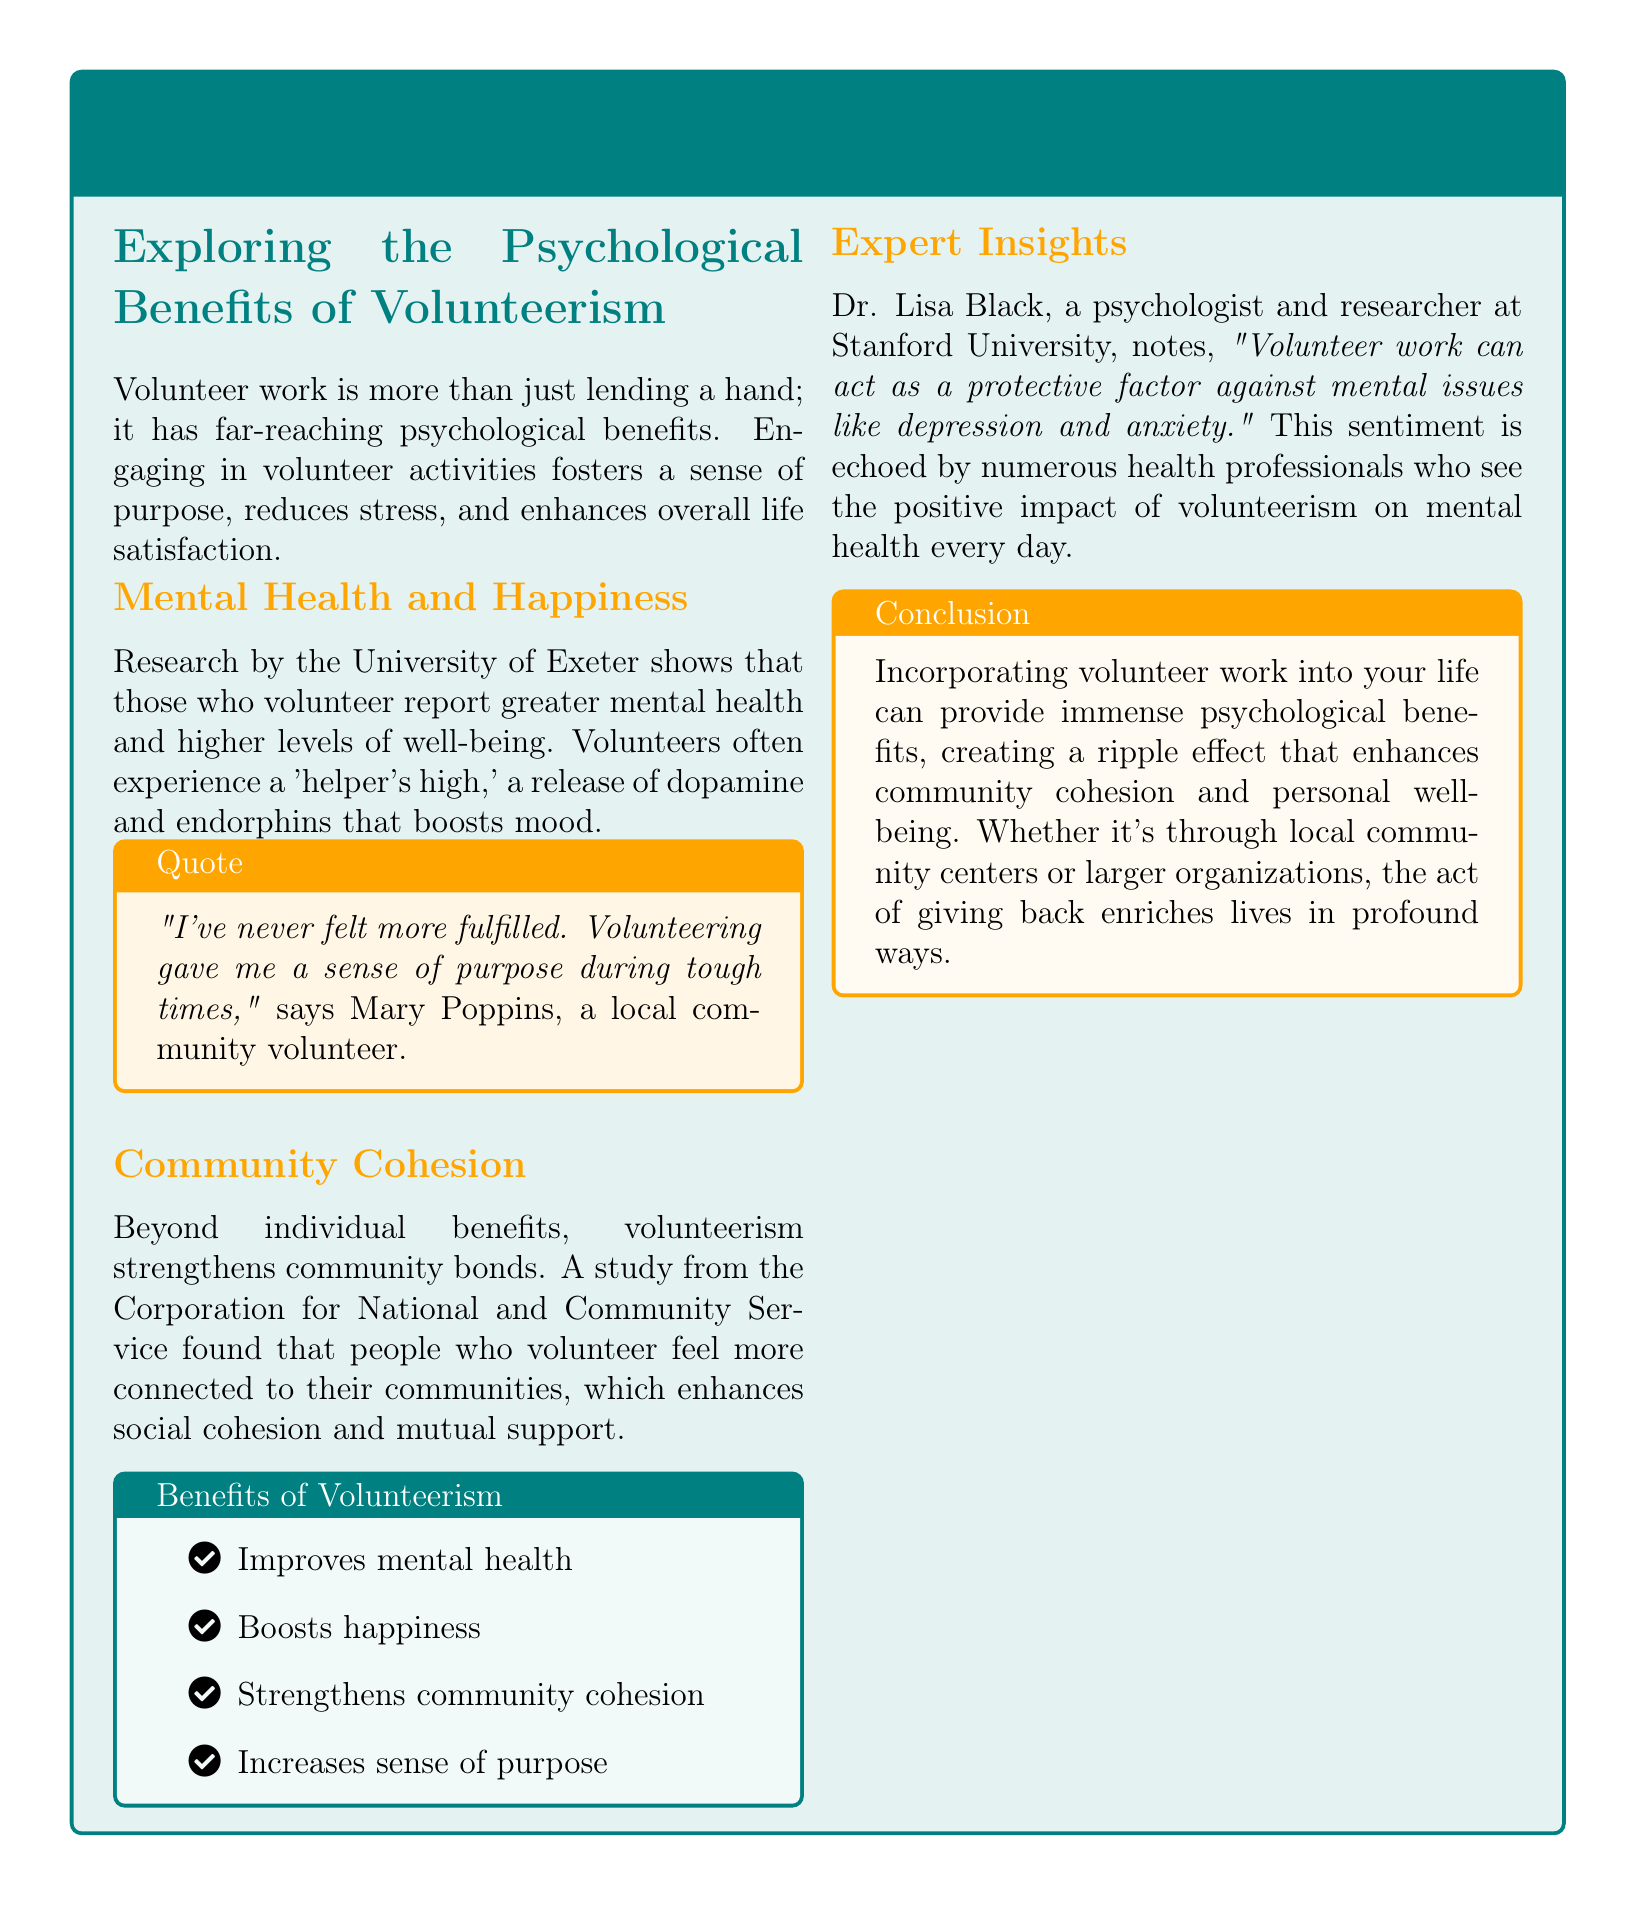What is the title of the article? The title is prominently displayed in the document's header area, emphasizing the main theme.
Answer: The Power of Community: Volunteerism and Its Psychological Impact Who conducted the research mentioned regarding mental health and happiness? The document references a specific institution that conducted research on the psychological benefits of volunteering.
Answer: University of Exeter What psychological phenomenon do volunteers often experience? This term illustrates the positive feelings and physical responses associated with volunteering, indicating its impact on mood.
Answer: 'helper's high' Who provided expert insights in the article? A specific individual's professional background and affiliation are highlighted as part of the expert opinions included.
Answer: Dr. Lisa Black What are some benefits of volunteerism listed in the document? The document includes a list of benefits presented in a structured format using bullet points, each starting with an icon.
Answer: Improves mental health, Boosts happiness, Strengthens community cohesion, Increases sense of purpose According to the article, how does volunteer work affect community bonds? The document discusses the broader implications of volunteering on community relationships and connections.
Answer: Strengthens community bonds In which university does Dr. Lisa Black work? The document provides information about the expert's affiliation, which adds credibility to the insights shared.
Answer: Stanford University What quote is attributed to Mary Poppins? A personal story is included in a text box, reflecting individual experiences related to volunteering.
Answer: "I've never felt more fulfilled. Volunteering gave me a sense of purpose during tough times." 